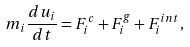Convert formula to latex. <formula><loc_0><loc_0><loc_500><loc_500>m _ { i } \frac { d u _ { i } } { d t } = F _ { i } ^ { c } + F _ { i } ^ { g } + F _ { i } ^ { i n t } ,</formula> 